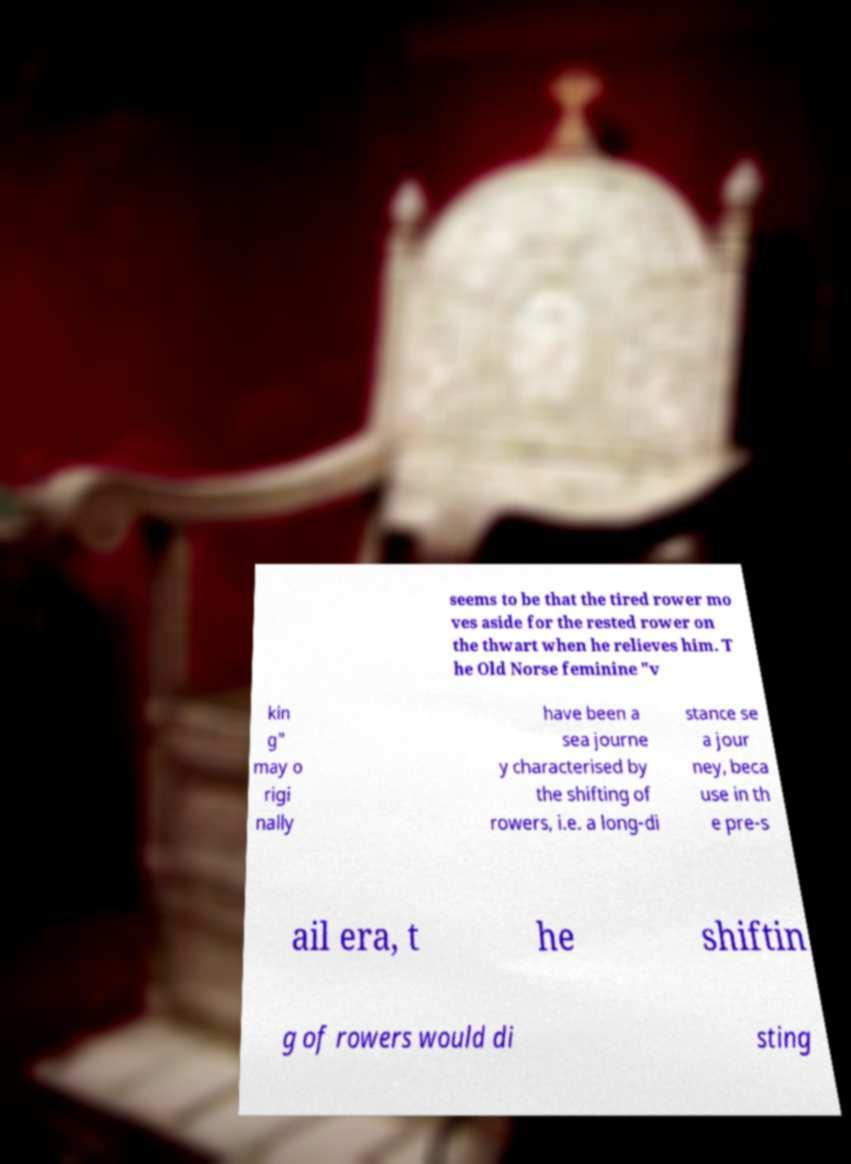Could you assist in decoding the text presented in this image and type it out clearly? seems to be that the tired rower mo ves aside for the rested rower on the thwart when he relieves him. T he Old Norse feminine "v kin g" may o rigi nally have been a sea journe y characterised by the shifting of rowers, i.e. a long-di stance se a jour ney, beca use in th e pre-s ail era, t he shiftin g of rowers would di sting 